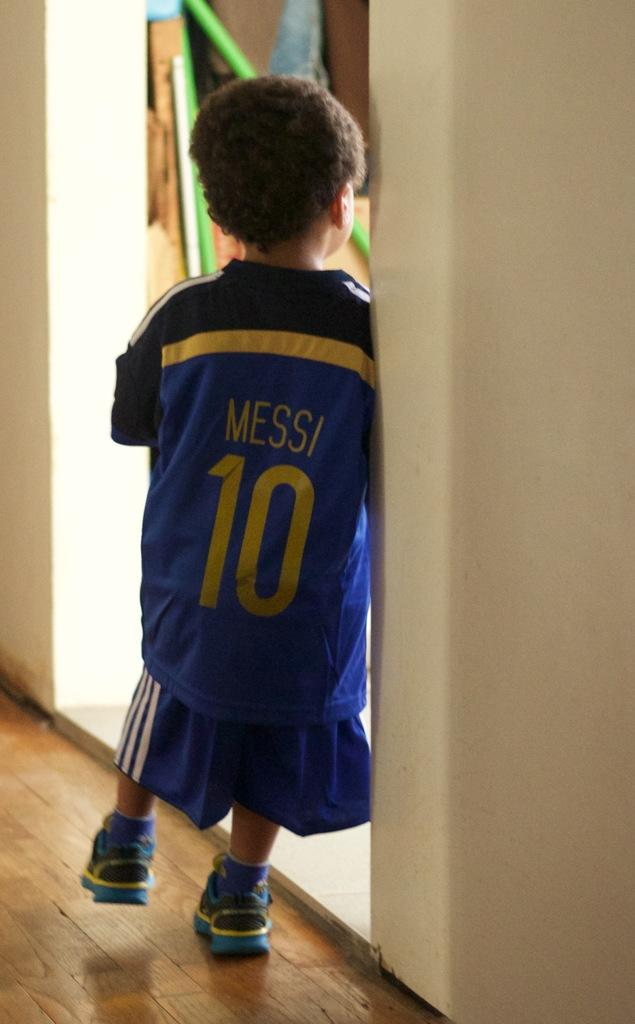Provide a one-sentence caption for the provided image. A young child is wearing a blue Jersey that says Messi 10 on it in yellow font. 